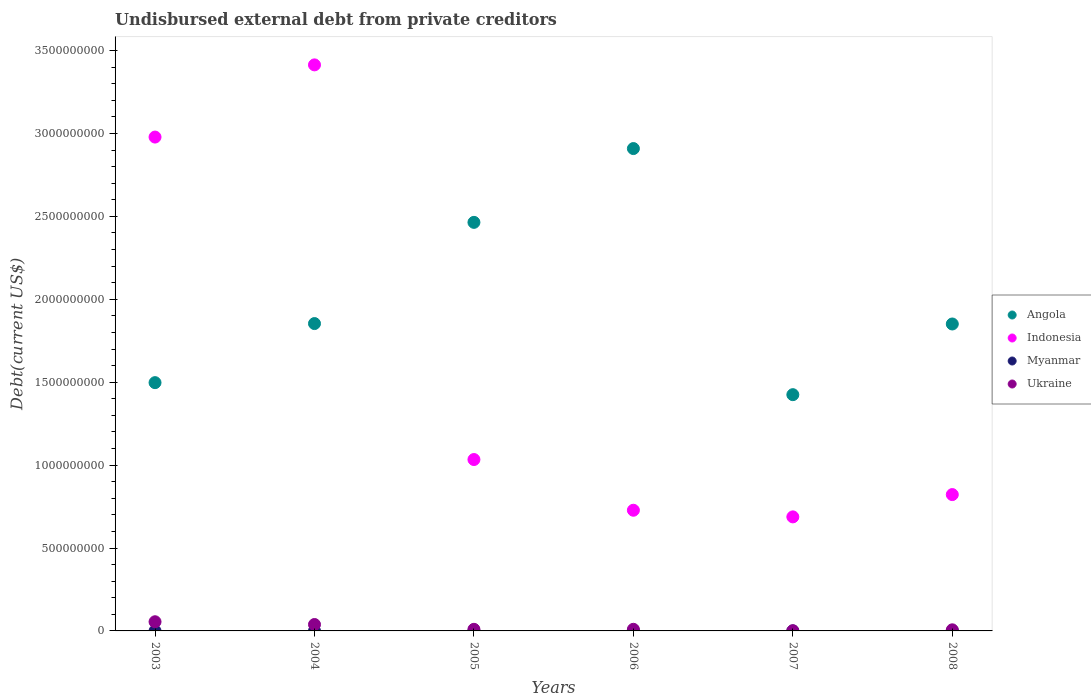Is the number of dotlines equal to the number of legend labels?
Give a very brief answer. Yes. What is the total debt in Ukraine in 2007?
Give a very brief answer. 1.13e+06. Across all years, what is the maximum total debt in Myanmar?
Your answer should be compact. 1.63e+05. Across all years, what is the minimum total debt in Indonesia?
Ensure brevity in your answer.  6.88e+08. In which year was the total debt in Indonesia maximum?
Provide a short and direct response. 2004. What is the total total debt in Angola in the graph?
Provide a succinct answer. 1.20e+1. What is the difference between the total debt in Ukraine in 2006 and that in 2008?
Keep it short and to the point. 3.13e+06. What is the difference between the total debt in Myanmar in 2003 and the total debt in Angola in 2007?
Offer a terse response. -1.42e+09. What is the average total debt in Angola per year?
Offer a very short reply. 2.00e+09. In the year 2008, what is the difference between the total debt in Indonesia and total debt in Myanmar?
Your answer should be very brief. 8.22e+08. Is the total debt in Indonesia in 2004 less than that in 2007?
Offer a very short reply. No. Is the difference between the total debt in Indonesia in 2003 and 2006 greater than the difference between the total debt in Myanmar in 2003 and 2006?
Your answer should be very brief. Yes. What is the difference between the highest and the second highest total debt in Ukraine?
Ensure brevity in your answer.  1.66e+07. What is the difference between the highest and the lowest total debt in Angola?
Make the answer very short. 1.48e+09. Is it the case that in every year, the sum of the total debt in Indonesia and total debt in Myanmar  is greater than the sum of total debt in Ukraine and total debt in Angola?
Offer a very short reply. Yes. Does the total debt in Indonesia monotonically increase over the years?
Make the answer very short. No. Is the total debt in Angola strictly greater than the total debt in Myanmar over the years?
Offer a very short reply. Yes. How many years are there in the graph?
Ensure brevity in your answer.  6. What is the difference between two consecutive major ticks on the Y-axis?
Make the answer very short. 5.00e+08. Where does the legend appear in the graph?
Provide a short and direct response. Center right. How many legend labels are there?
Your answer should be very brief. 4. What is the title of the graph?
Provide a succinct answer. Undisbursed external debt from private creditors. What is the label or title of the X-axis?
Give a very brief answer. Years. What is the label or title of the Y-axis?
Offer a very short reply. Debt(current US$). What is the Debt(current US$) of Angola in 2003?
Give a very brief answer. 1.50e+09. What is the Debt(current US$) in Indonesia in 2003?
Make the answer very short. 2.98e+09. What is the Debt(current US$) in Myanmar in 2003?
Keep it short and to the point. 1.63e+05. What is the Debt(current US$) in Ukraine in 2003?
Provide a short and direct response. 5.53e+07. What is the Debt(current US$) in Angola in 2004?
Keep it short and to the point. 1.85e+09. What is the Debt(current US$) of Indonesia in 2004?
Make the answer very short. 3.41e+09. What is the Debt(current US$) in Myanmar in 2004?
Offer a terse response. 4.70e+04. What is the Debt(current US$) in Ukraine in 2004?
Keep it short and to the point. 3.87e+07. What is the Debt(current US$) of Angola in 2005?
Offer a very short reply. 2.46e+09. What is the Debt(current US$) in Indonesia in 2005?
Your answer should be very brief. 1.03e+09. What is the Debt(current US$) in Myanmar in 2005?
Offer a very short reply. 4.70e+04. What is the Debt(current US$) in Ukraine in 2005?
Your response must be concise. 9.66e+06. What is the Debt(current US$) in Angola in 2006?
Your answer should be compact. 2.91e+09. What is the Debt(current US$) of Indonesia in 2006?
Provide a succinct answer. 7.28e+08. What is the Debt(current US$) in Myanmar in 2006?
Your answer should be very brief. 4.70e+04. What is the Debt(current US$) in Ukraine in 2006?
Give a very brief answer. 9.76e+06. What is the Debt(current US$) of Angola in 2007?
Provide a short and direct response. 1.42e+09. What is the Debt(current US$) of Indonesia in 2007?
Give a very brief answer. 6.88e+08. What is the Debt(current US$) in Myanmar in 2007?
Your response must be concise. 4.70e+04. What is the Debt(current US$) of Ukraine in 2007?
Ensure brevity in your answer.  1.13e+06. What is the Debt(current US$) of Angola in 2008?
Give a very brief answer. 1.85e+09. What is the Debt(current US$) in Indonesia in 2008?
Keep it short and to the point. 8.22e+08. What is the Debt(current US$) in Myanmar in 2008?
Offer a very short reply. 4.70e+04. What is the Debt(current US$) in Ukraine in 2008?
Your response must be concise. 6.63e+06. Across all years, what is the maximum Debt(current US$) of Angola?
Your answer should be compact. 2.91e+09. Across all years, what is the maximum Debt(current US$) of Indonesia?
Keep it short and to the point. 3.41e+09. Across all years, what is the maximum Debt(current US$) of Myanmar?
Offer a very short reply. 1.63e+05. Across all years, what is the maximum Debt(current US$) in Ukraine?
Ensure brevity in your answer.  5.53e+07. Across all years, what is the minimum Debt(current US$) in Angola?
Ensure brevity in your answer.  1.42e+09. Across all years, what is the minimum Debt(current US$) of Indonesia?
Ensure brevity in your answer.  6.88e+08. Across all years, what is the minimum Debt(current US$) in Myanmar?
Provide a short and direct response. 4.70e+04. Across all years, what is the minimum Debt(current US$) in Ukraine?
Your answer should be very brief. 1.13e+06. What is the total Debt(current US$) of Angola in the graph?
Offer a very short reply. 1.20e+1. What is the total Debt(current US$) of Indonesia in the graph?
Your response must be concise. 9.66e+09. What is the total Debt(current US$) of Myanmar in the graph?
Offer a terse response. 3.98e+05. What is the total Debt(current US$) in Ukraine in the graph?
Your answer should be compact. 1.21e+08. What is the difference between the Debt(current US$) in Angola in 2003 and that in 2004?
Provide a succinct answer. -3.56e+08. What is the difference between the Debt(current US$) in Indonesia in 2003 and that in 2004?
Your answer should be compact. -4.35e+08. What is the difference between the Debt(current US$) in Myanmar in 2003 and that in 2004?
Make the answer very short. 1.16e+05. What is the difference between the Debt(current US$) in Ukraine in 2003 and that in 2004?
Offer a terse response. 1.66e+07. What is the difference between the Debt(current US$) of Angola in 2003 and that in 2005?
Your response must be concise. -9.67e+08. What is the difference between the Debt(current US$) in Indonesia in 2003 and that in 2005?
Ensure brevity in your answer.  1.94e+09. What is the difference between the Debt(current US$) of Myanmar in 2003 and that in 2005?
Offer a terse response. 1.16e+05. What is the difference between the Debt(current US$) in Ukraine in 2003 and that in 2005?
Your answer should be compact. 4.56e+07. What is the difference between the Debt(current US$) in Angola in 2003 and that in 2006?
Provide a succinct answer. -1.41e+09. What is the difference between the Debt(current US$) in Indonesia in 2003 and that in 2006?
Ensure brevity in your answer.  2.25e+09. What is the difference between the Debt(current US$) of Myanmar in 2003 and that in 2006?
Provide a short and direct response. 1.16e+05. What is the difference between the Debt(current US$) of Ukraine in 2003 and that in 2006?
Your answer should be very brief. 4.55e+07. What is the difference between the Debt(current US$) in Angola in 2003 and that in 2007?
Ensure brevity in your answer.  7.25e+07. What is the difference between the Debt(current US$) of Indonesia in 2003 and that in 2007?
Provide a short and direct response. 2.29e+09. What is the difference between the Debt(current US$) in Myanmar in 2003 and that in 2007?
Make the answer very short. 1.16e+05. What is the difference between the Debt(current US$) in Ukraine in 2003 and that in 2007?
Provide a succinct answer. 5.42e+07. What is the difference between the Debt(current US$) of Angola in 2003 and that in 2008?
Your answer should be compact. -3.54e+08. What is the difference between the Debt(current US$) in Indonesia in 2003 and that in 2008?
Offer a very short reply. 2.16e+09. What is the difference between the Debt(current US$) in Myanmar in 2003 and that in 2008?
Keep it short and to the point. 1.16e+05. What is the difference between the Debt(current US$) of Ukraine in 2003 and that in 2008?
Your response must be concise. 4.87e+07. What is the difference between the Debt(current US$) in Angola in 2004 and that in 2005?
Provide a succinct answer. -6.10e+08. What is the difference between the Debt(current US$) in Indonesia in 2004 and that in 2005?
Keep it short and to the point. 2.38e+09. What is the difference between the Debt(current US$) of Myanmar in 2004 and that in 2005?
Make the answer very short. 0. What is the difference between the Debt(current US$) in Ukraine in 2004 and that in 2005?
Provide a short and direct response. 2.90e+07. What is the difference between the Debt(current US$) in Angola in 2004 and that in 2006?
Your response must be concise. -1.06e+09. What is the difference between the Debt(current US$) in Indonesia in 2004 and that in 2006?
Keep it short and to the point. 2.69e+09. What is the difference between the Debt(current US$) in Myanmar in 2004 and that in 2006?
Make the answer very short. 0. What is the difference between the Debt(current US$) in Ukraine in 2004 and that in 2006?
Provide a succinct answer. 2.89e+07. What is the difference between the Debt(current US$) of Angola in 2004 and that in 2007?
Your answer should be very brief. 4.29e+08. What is the difference between the Debt(current US$) in Indonesia in 2004 and that in 2007?
Provide a succinct answer. 2.73e+09. What is the difference between the Debt(current US$) in Ukraine in 2004 and that in 2007?
Your answer should be very brief. 3.75e+07. What is the difference between the Debt(current US$) of Angola in 2004 and that in 2008?
Offer a terse response. 2.51e+06. What is the difference between the Debt(current US$) of Indonesia in 2004 and that in 2008?
Give a very brief answer. 2.59e+09. What is the difference between the Debt(current US$) of Ukraine in 2004 and that in 2008?
Keep it short and to the point. 3.20e+07. What is the difference between the Debt(current US$) in Angola in 2005 and that in 2006?
Your answer should be compact. -4.45e+08. What is the difference between the Debt(current US$) of Indonesia in 2005 and that in 2006?
Offer a terse response. 3.06e+08. What is the difference between the Debt(current US$) of Ukraine in 2005 and that in 2006?
Offer a very short reply. -1.05e+05. What is the difference between the Debt(current US$) of Angola in 2005 and that in 2007?
Your response must be concise. 1.04e+09. What is the difference between the Debt(current US$) of Indonesia in 2005 and that in 2007?
Offer a very short reply. 3.46e+08. What is the difference between the Debt(current US$) in Myanmar in 2005 and that in 2007?
Make the answer very short. 0. What is the difference between the Debt(current US$) of Ukraine in 2005 and that in 2007?
Provide a succinct answer. 8.53e+06. What is the difference between the Debt(current US$) of Angola in 2005 and that in 2008?
Ensure brevity in your answer.  6.13e+08. What is the difference between the Debt(current US$) in Indonesia in 2005 and that in 2008?
Give a very brief answer. 2.11e+08. What is the difference between the Debt(current US$) of Ukraine in 2005 and that in 2008?
Offer a terse response. 3.02e+06. What is the difference between the Debt(current US$) of Angola in 2006 and that in 2007?
Provide a short and direct response. 1.48e+09. What is the difference between the Debt(current US$) of Indonesia in 2006 and that in 2007?
Provide a short and direct response. 4.00e+07. What is the difference between the Debt(current US$) of Ukraine in 2006 and that in 2007?
Ensure brevity in your answer.  8.63e+06. What is the difference between the Debt(current US$) of Angola in 2006 and that in 2008?
Offer a terse response. 1.06e+09. What is the difference between the Debt(current US$) in Indonesia in 2006 and that in 2008?
Your answer should be very brief. -9.44e+07. What is the difference between the Debt(current US$) of Myanmar in 2006 and that in 2008?
Provide a short and direct response. 0. What is the difference between the Debt(current US$) in Ukraine in 2006 and that in 2008?
Keep it short and to the point. 3.13e+06. What is the difference between the Debt(current US$) of Angola in 2007 and that in 2008?
Provide a short and direct response. -4.26e+08. What is the difference between the Debt(current US$) of Indonesia in 2007 and that in 2008?
Give a very brief answer. -1.34e+08. What is the difference between the Debt(current US$) of Myanmar in 2007 and that in 2008?
Provide a succinct answer. 0. What is the difference between the Debt(current US$) of Ukraine in 2007 and that in 2008?
Provide a succinct answer. -5.50e+06. What is the difference between the Debt(current US$) of Angola in 2003 and the Debt(current US$) of Indonesia in 2004?
Your answer should be very brief. -1.92e+09. What is the difference between the Debt(current US$) of Angola in 2003 and the Debt(current US$) of Myanmar in 2004?
Keep it short and to the point. 1.50e+09. What is the difference between the Debt(current US$) of Angola in 2003 and the Debt(current US$) of Ukraine in 2004?
Your answer should be very brief. 1.46e+09. What is the difference between the Debt(current US$) of Indonesia in 2003 and the Debt(current US$) of Myanmar in 2004?
Offer a terse response. 2.98e+09. What is the difference between the Debt(current US$) of Indonesia in 2003 and the Debt(current US$) of Ukraine in 2004?
Your answer should be compact. 2.94e+09. What is the difference between the Debt(current US$) in Myanmar in 2003 and the Debt(current US$) in Ukraine in 2004?
Your answer should be compact. -3.85e+07. What is the difference between the Debt(current US$) of Angola in 2003 and the Debt(current US$) of Indonesia in 2005?
Give a very brief answer. 4.64e+08. What is the difference between the Debt(current US$) in Angola in 2003 and the Debt(current US$) in Myanmar in 2005?
Your answer should be very brief. 1.50e+09. What is the difference between the Debt(current US$) of Angola in 2003 and the Debt(current US$) of Ukraine in 2005?
Your response must be concise. 1.49e+09. What is the difference between the Debt(current US$) of Indonesia in 2003 and the Debt(current US$) of Myanmar in 2005?
Keep it short and to the point. 2.98e+09. What is the difference between the Debt(current US$) of Indonesia in 2003 and the Debt(current US$) of Ukraine in 2005?
Offer a terse response. 2.97e+09. What is the difference between the Debt(current US$) in Myanmar in 2003 and the Debt(current US$) in Ukraine in 2005?
Keep it short and to the point. -9.49e+06. What is the difference between the Debt(current US$) of Angola in 2003 and the Debt(current US$) of Indonesia in 2006?
Your answer should be compact. 7.69e+08. What is the difference between the Debt(current US$) in Angola in 2003 and the Debt(current US$) in Myanmar in 2006?
Provide a short and direct response. 1.50e+09. What is the difference between the Debt(current US$) in Angola in 2003 and the Debt(current US$) in Ukraine in 2006?
Ensure brevity in your answer.  1.49e+09. What is the difference between the Debt(current US$) of Indonesia in 2003 and the Debt(current US$) of Myanmar in 2006?
Your answer should be compact. 2.98e+09. What is the difference between the Debt(current US$) of Indonesia in 2003 and the Debt(current US$) of Ukraine in 2006?
Your answer should be very brief. 2.97e+09. What is the difference between the Debt(current US$) in Myanmar in 2003 and the Debt(current US$) in Ukraine in 2006?
Ensure brevity in your answer.  -9.60e+06. What is the difference between the Debt(current US$) of Angola in 2003 and the Debt(current US$) of Indonesia in 2007?
Make the answer very short. 8.10e+08. What is the difference between the Debt(current US$) in Angola in 2003 and the Debt(current US$) in Myanmar in 2007?
Ensure brevity in your answer.  1.50e+09. What is the difference between the Debt(current US$) in Angola in 2003 and the Debt(current US$) in Ukraine in 2007?
Your response must be concise. 1.50e+09. What is the difference between the Debt(current US$) of Indonesia in 2003 and the Debt(current US$) of Myanmar in 2007?
Provide a succinct answer. 2.98e+09. What is the difference between the Debt(current US$) of Indonesia in 2003 and the Debt(current US$) of Ukraine in 2007?
Your response must be concise. 2.98e+09. What is the difference between the Debt(current US$) in Myanmar in 2003 and the Debt(current US$) in Ukraine in 2007?
Your response must be concise. -9.65e+05. What is the difference between the Debt(current US$) in Angola in 2003 and the Debt(current US$) in Indonesia in 2008?
Your answer should be very brief. 6.75e+08. What is the difference between the Debt(current US$) of Angola in 2003 and the Debt(current US$) of Myanmar in 2008?
Ensure brevity in your answer.  1.50e+09. What is the difference between the Debt(current US$) of Angola in 2003 and the Debt(current US$) of Ukraine in 2008?
Your answer should be compact. 1.49e+09. What is the difference between the Debt(current US$) in Indonesia in 2003 and the Debt(current US$) in Myanmar in 2008?
Offer a very short reply. 2.98e+09. What is the difference between the Debt(current US$) in Indonesia in 2003 and the Debt(current US$) in Ukraine in 2008?
Provide a short and direct response. 2.97e+09. What is the difference between the Debt(current US$) of Myanmar in 2003 and the Debt(current US$) of Ukraine in 2008?
Your response must be concise. -6.47e+06. What is the difference between the Debt(current US$) of Angola in 2004 and the Debt(current US$) of Indonesia in 2005?
Offer a very short reply. 8.20e+08. What is the difference between the Debt(current US$) of Angola in 2004 and the Debt(current US$) of Myanmar in 2005?
Provide a short and direct response. 1.85e+09. What is the difference between the Debt(current US$) in Angola in 2004 and the Debt(current US$) in Ukraine in 2005?
Your answer should be compact. 1.84e+09. What is the difference between the Debt(current US$) of Indonesia in 2004 and the Debt(current US$) of Myanmar in 2005?
Make the answer very short. 3.41e+09. What is the difference between the Debt(current US$) of Indonesia in 2004 and the Debt(current US$) of Ukraine in 2005?
Keep it short and to the point. 3.40e+09. What is the difference between the Debt(current US$) in Myanmar in 2004 and the Debt(current US$) in Ukraine in 2005?
Offer a very short reply. -9.61e+06. What is the difference between the Debt(current US$) of Angola in 2004 and the Debt(current US$) of Indonesia in 2006?
Make the answer very short. 1.13e+09. What is the difference between the Debt(current US$) of Angola in 2004 and the Debt(current US$) of Myanmar in 2006?
Give a very brief answer. 1.85e+09. What is the difference between the Debt(current US$) of Angola in 2004 and the Debt(current US$) of Ukraine in 2006?
Make the answer very short. 1.84e+09. What is the difference between the Debt(current US$) of Indonesia in 2004 and the Debt(current US$) of Myanmar in 2006?
Make the answer very short. 3.41e+09. What is the difference between the Debt(current US$) in Indonesia in 2004 and the Debt(current US$) in Ukraine in 2006?
Offer a very short reply. 3.40e+09. What is the difference between the Debt(current US$) in Myanmar in 2004 and the Debt(current US$) in Ukraine in 2006?
Provide a succinct answer. -9.71e+06. What is the difference between the Debt(current US$) in Angola in 2004 and the Debt(current US$) in Indonesia in 2007?
Ensure brevity in your answer.  1.17e+09. What is the difference between the Debt(current US$) of Angola in 2004 and the Debt(current US$) of Myanmar in 2007?
Your answer should be very brief. 1.85e+09. What is the difference between the Debt(current US$) in Angola in 2004 and the Debt(current US$) in Ukraine in 2007?
Keep it short and to the point. 1.85e+09. What is the difference between the Debt(current US$) in Indonesia in 2004 and the Debt(current US$) in Myanmar in 2007?
Make the answer very short. 3.41e+09. What is the difference between the Debt(current US$) of Indonesia in 2004 and the Debt(current US$) of Ukraine in 2007?
Make the answer very short. 3.41e+09. What is the difference between the Debt(current US$) in Myanmar in 2004 and the Debt(current US$) in Ukraine in 2007?
Offer a very short reply. -1.08e+06. What is the difference between the Debt(current US$) of Angola in 2004 and the Debt(current US$) of Indonesia in 2008?
Ensure brevity in your answer.  1.03e+09. What is the difference between the Debt(current US$) of Angola in 2004 and the Debt(current US$) of Myanmar in 2008?
Your answer should be very brief. 1.85e+09. What is the difference between the Debt(current US$) of Angola in 2004 and the Debt(current US$) of Ukraine in 2008?
Provide a short and direct response. 1.85e+09. What is the difference between the Debt(current US$) of Indonesia in 2004 and the Debt(current US$) of Myanmar in 2008?
Provide a succinct answer. 3.41e+09. What is the difference between the Debt(current US$) of Indonesia in 2004 and the Debt(current US$) of Ukraine in 2008?
Offer a terse response. 3.41e+09. What is the difference between the Debt(current US$) in Myanmar in 2004 and the Debt(current US$) in Ukraine in 2008?
Offer a very short reply. -6.59e+06. What is the difference between the Debt(current US$) in Angola in 2005 and the Debt(current US$) in Indonesia in 2006?
Your response must be concise. 1.74e+09. What is the difference between the Debt(current US$) in Angola in 2005 and the Debt(current US$) in Myanmar in 2006?
Your answer should be compact. 2.46e+09. What is the difference between the Debt(current US$) in Angola in 2005 and the Debt(current US$) in Ukraine in 2006?
Provide a succinct answer. 2.45e+09. What is the difference between the Debt(current US$) in Indonesia in 2005 and the Debt(current US$) in Myanmar in 2006?
Offer a very short reply. 1.03e+09. What is the difference between the Debt(current US$) of Indonesia in 2005 and the Debt(current US$) of Ukraine in 2006?
Your answer should be compact. 1.02e+09. What is the difference between the Debt(current US$) in Myanmar in 2005 and the Debt(current US$) in Ukraine in 2006?
Ensure brevity in your answer.  -9.71e+06. What is the difference between the Debt(current US$) of Angola in 2005 and the Debt(current US$) of Indonesia in 2007?
Provide a succinct answer. 1.78e+09. What is the difference between the Debt(current US$) in Angola in 2005 and the Debt(current US$) in Myanmar in 2007?
Your answer should be very brief. 2.46e+09. What is the difference between the Debt(current US$) in Angola in 2005 and the Debt(current US$) in Ukraine in 2007?
Provide a short and direct response. 2.46e+09. What is the difference between the Debt(current US$) of Indonesia in 2005 and the Debt(current US$) of Myanmar in 2007?
Your answer should be very brief. 1.03e+09. What is the difference between the Debt(current US$) in Indonesia in 2005 and the Debt(current US$) in Ukraine in 2007?
Ensure brevity in your answer.  1.03e+09. What is the difference between the Debt(current US$) in Myanmar in 2005 and the Debt(current US$) in Ukraine in 2007?
Offer a terse response. -1.08e+06. What is the difference between the Debt(current US$) of Angola in 2005 and the Debt(current US$) of Indonesia in 2008?
Make the answer very short. 1.64e+09. What is the difference between the Debt(current US$) in Angola in 2005 and the Debt(current US$) in Myanmar in 2008?
Make the answer very short. 2.46e+09. What is the difference between the Debt(current US$) of Angola in 2005 and the Debt(current US$) of Ukraine in 2008?
Make the answer very short. 2.46e+09. What is the difference between the Debt(current US$) in Indonesia in 2005 and the Debt(current US$) in Myanmar in 2008?
Make the answer very short. 1.03e+09. What is the difference between the Debt(current US$) of Indonesia in 2005 and the Debt(current US$) of Ukraine in 2008?
Make the answer very short. 1.03e+09. What is the difference between the Debt(current US$) of Myanmar in 2005 and the Debt(current US$) of Ukraine in 2008?
Offer a terse response. -6.59e+06. What is the difference between the Debt(current US$) of Angola in 2006 and the Debt(current US$) of Indonesia in 2007?
Your response must be concise. 2.22e+09. What is the difference between the Debt(current US$) in Angola in 2006 and the Debt(current US$) in Myanmar in 2007?
Your answer should be very brief. 2.91e+09. What is the difference between the Debt(current US$) of Angola in 2006 and the Debt(current US$) of Ukraine in 2007?
Your response must be concise. 2.91e+09. What is the difference between the Debt(current US$) in Indonesia in 2006 and the Debt(current US$) in Myanmar in 2007?
Provide a succinct answer. 7.28e+08. What is the difference between the Debt(current US$) in Indonesia in 2006 and the Debt(current US$) in Ukraine in 2007?
Your answer should be compact. 7.27e+08. What is the difference between the Debt(current US$) of Myanmar in 2006 and the Debt(current US$) of Ukraine in 2007?
Ensure brevity in your answer.  -1.08e+06. What is the difference between the Debt(current US$) in Angola in 2006 and the Debt(current US$) in Indonesia in 2008?
Your answer should be compact. 2.09e+09. What is the difference between the Debt(current US$) of Angola in 2006 and the Debt(current US$) of Myanmar in 2008?
Provide a short and direct response. 2.91e+09. What is the difference between the Debt(current US$) in Angola in 2006 and the Debt(current US$) in Ukraine in 2008?
Your answer should be very brief. 2.90e+09. What is the difference between the Debt(current US$) of Indonesia in 2006 and the Debt(current US$) of Myanmar in 2008?
Make the answer very short. 7.28e+08. What is the difference between the Debt(current US$) of Indonesia in 2006 and the Debt(current US$) of Ukraine in 2008?
Ensure brevity in your answer.  7.21e+08. What is the difference between the Debt(current US$) of Myanmar in 2006 and the Debt(current US$) of Ukraine in 2008?
Make the answer very short. -6.59e+06. What is the difference between the Debt(current US$) in Angola in 2007 and the Debt(current US$) in Indonesia in 2008?
Offer a terse response. 6.03e+08. What is the difference between the Debt(current US$) of Angola in 2007 and the Debt(current US$) of Myanmar in 2008?
Offer a terse response. 1.42e+09. What is the difference between the Debt(current US$) of Angola in 2007 and the Debt(current US$) of Ukraine in 2008?
Your response must be concise. 1.42e+09. What is the difference between the Debt(current US$) in Indonesia in 2007 and the Debt(current US$) in Myanmar in 2008?
Your answer should be compact. 6.88e+08. What is the difference between the Debt(current US$) of Indonesia in 2007 and the Debt(current US$) of Ukraine in 2008?
Provide a succinct answer. 6.81e+08. What is the difference between the Debt(current US$) of Myanmar in 2007 and the Debt(current US$) of Ukraine in 2008?
Provide a succinct answer. -6.59e+06. What is the average Debt(current US$) of Angola per year?
Offer a very short reply. 2.00e+09. What is the average Debt(current US$) in Indonesia per year?
Provide a short and direct response. 1.61e+09. What is the average Debt(current US$) of Myanmar per year?
Your answer should be compact. 6.63e+04. What is the average Debt(current US$) of Ukraine per year?
Give a very brief answer. 2.02e+07. In the year 2003, what is the difference between the Debt(current US$) of Angola and Debt(current US$) of Indonesia?
Keep it short and to the point. -1.48e+09. In the year 2003, what is the difference between the Debt(current US$) in Angola and Debt(current US$) in Myanmar?
Give a very brief answer. 1.50e+09. In the year 2003, what is the difference between the Debt(current US$) of Angola and Debt(current US$) of Ukraine?
Provide a succinct answer. 1.44e+09. In the year 2003, what is the difference between the Debt(current US$) in Indonesia and Debt(current US$) in Myanmar?
Your answer should be compact. 2.98e+09. In the year 2003, what is the difference between the Debt(current US$) in Indonesia and Debt(current US$) in Ukraine?
Keep it short and to the point. 2.92e+09. In the year 2003, what is the difference between the Debt(current US$) of Myanmar and Debt(current US$) of Ukraine?
Your response must be concise. -5.51e+07. In the year 2004, what is the difference between the Debt(current US$) in Angola and Debt(current US$) in Indonesia?
Ensure brevity in your answer.  -1.56e+09. In the year 2004, what is the difference between the Debt(current US$) of Angola and Debt(current US$) of Myanmar?
Your response must be concise. 1.85e+09. In the year 2004, what is the difference between the Debt(current US$) in Angola and Debt(current US$) in Ukraine?
Provide a succinct answer. 1.81e+09. In the year 2004, what is the difference between the Debt(current US$) of Indonesia and Debt(current US$) of Myanmar?
Keep it short and to the point. 3.41e+09. In the year 2004, what is the difference between the Debt(current US$) of Indonesia and Debt(current US$) of Ukraine?
Provide a succinct answer. 3.37e+09. In the year 2004, what is the difference between the Debt(current US$) in Myanmar and Debt(current US$) in Ukraine?
Your response must be concise. -3.86e+07. In the year 2005, what is the difference between the Debt(current US$) of Angola and Debt(current US$) of Indonesia?
Ensure brevity in your answer.  1.43e+09. In the year 2005, what is the difference between the Debt(current US$) in Angola and Debt(current US$) in Myanmar?
Make the answer very short. 2.46e+09. In the year 2005, what is the difference between the Debt(current US$) of Angola and Debt(current US$) of Ukraine?
Your answer should be very brief. 2.45e+09. In the year 2005, what is the difference between the Debt(current US$) of Indonesia and Debt(current US$) of Myanmar?
Your answer should be very brief. 1.03e+09. In the year 2005, what is the difference between the Debt(current US$) of Indonesia and Debt(current US$) of Ukraine?
Keep it short and to the point. 1.02e+09. In the year 2005, what is the difference between the Debt(current US$) of Myanmar and Debt(current US$) of Ukraine?
Offer a terse response. -9.61e+06. In the year 2006, what is the difference between the Debt(current US$) in Angola and Debt(current US$) in Indonesia?
Make the answer very short. 2.18e+09. In the year 2006, what is the difference between the Debt(current US$) in Angola and Debt(current US$) in Myanmar?
Your answer should be compact. 2.91e+09. In the year 2006, what is the difference between the Debt(current US$) of Angola and Debt(current US$) of Ukraine?
Your answer should be very brief. 2.90e+09. In the year 2006, what is the difference between the Debt(current US$) in Indonesia and Debt(current US$) in Myanmar?
Offer a very short reply. 7.28e+08. In the year 2006, what is the difference between the Debt(current US$) in Indonesia and Debt(current US$) in Ukraine?
Your answer should be very brief. 7.18e+08. In the year 2006, what is the difference between the Debt(current US$) of Myanmar and Debt(current US$) of Ukraine?
Offer a terse response. -9.71e+06. In the year 2007, what is the difference between the Debt(current US$) in Angola and Debt(current US$) in Indonesia?
Give a very brief answer. 7.37e+08. In the year 2007, what is the difference between the Debt(current US$) in Angola and Debt(current US$) in Myanmar?
Provide a short and direct response. 1.42e+09. In the year 2007, what is the difference between the Debt(current US$) in Angola and Debt(current US$) in Ukraine?
Keep it short and to the point. 1.42e+09. In the year 2007, what is the difference between the Debt(current US$) of Indonesia and Debt(current US$) of Myanmar?
Offer a terse response. 6.88e+08. In the year 2007, what is the difference between the Debt(current US$) in Indonesia and Debt(current US$) in Ukraine?
Keep it short and to the point. 6.87e+08. In the year 2007, what is the difference between the Debt(current US$) in Myanmar and Debt(current US$) in Ukraine?
Offer a terse response. -1.08e+06. In the year 2008, what is the difference between the Debt(current US$) of Angola and Debt(current US$) of Indonesia?
Make the answer very short. 1.03e+09. In the year 2008, what is the difference between the Debt(current US$) in Angola and Debt(current US$) in Myanmar?
Your answer should be compact. 1.85e+09. In the year 2008, what is the difference between the Debt(current US$) of Angola and Debt(current US$) of Ukraine?
Provide a short and direct response. 1.84e+09. In the year 2008, what is the difference between the Debt(current US$) in Indonesia and Debt(current US$) in Myanmar?
Provide a short and direct response. 8.22e+08. In the year 2008, what is the difference between the Debt(current US$) in Indonesia and Debt(current US$) in Ukraine?
Provide a succinct answer. 8.16e+08. In the year 2008, what is the difference between the Debt(current US$) of Myanmar and Debt(current US$) of Ukraine?
Keep it short and to the point. -6.59e+06. What is the ratio of the Debt(current US$) of Angola in 2003 to that in 2004?
Your answer should be very brief. 0.81. What is the ratio of the Debt(current US$) of Indonesia in 2003 to that in 2004?
Ensure brevity in your answer.  0.87. What is the ratio of the Debt(current US$) in Myanmar in 2003 to that in 2004?
Keep it short and to the point. 3.47. What is the ratio of the Debt(current US$) of Ukraine in 2003 to that in 2004?
Your answer should be very brief. 1.43. What is the ratio of the Debt(current US$) in Angola in 2003 to that in 2005?
Ensure brevity in your answer.  0.61. What is the ratio of the Debt(current US$) of Indonesia in 2003 to that in 2005?
Your answer should be compact. 2.88. What is the ratio of the Debt(current US$) of Myanmar in 2003 to that in 2005?
Offer a terse response. 3.47. What is the ratio of the Debt(current US$) of Ukraine in 2003 to that in 2005?
Give a very brief answer. 5.73. What is the ratio of the Debt(current US$) in Angola in 2003 to that in 2006?
Offer a terse response. 0.51. What is the ratio of the Debt(current US$) of Indonesia in 2003 to that in 2006?
Offer a very short reply. 4.09. What is the ratio of the Debt(current US$) in Myanmar in 2003 to that in 2006?
Make the answer very short. 3.47. What is the ratio of the Debt(current US$) in Ukraine in 2003 to that in 2006?
Provide a short and direct response. 5.67. What is the ratio of the Debt(current US$) in Angola in 2003 to that in 2007?
Offer a very short reply. 1.05. What is the ratio of the Debt(current US$) of Indonesia in 2003 to that in 2007?
Provide a succinct answer. 4.33. What is the ratio of the Debt(current US$) in Myanmar in 2003 to that in 2007?
Make the answer very short. 3.47. What is the ratio of the Debt(current US$) of Ukraine in 2003 to that in 2007?
Your response must be concise. 49.03. What is the ratio of the Debt(current US$) in Angola in 2003 to that in 2008?
Keep it short and to the point. 0.81. What is the ratio of the Debt(current US$) in Indonesia in 2003 to that in 2008?
Ensure brevity in your answer.  3.62. What is the ratio of the Debt(current US$) of Myanmar in 2003 to that in 2008?
Ensure brevity in your answer.  3.47. What is the ratio of the Debt(current US$) in Ukraine in 2003 to that in 2008?
Ensure brevity in your answer.  8.34. What is the ratio of the Debt(current US$) in Angola in 2004 to that in 2005?
Make the answer very short. 0.75. What is the ratio of the Debt(current US$) in Indonesia in 2004 to that in 2005?
Offer a very short reply. 3.3. What is the ratio of the Debt(current US$) of Ukraine in 2004 to that in 2005?
Provide a succinct answer. 4.01. What is the ratio of the Debt(current US$) of Angola in 2004 to that in 2006?
Make the answer very short. 0.64. What is the ratio of the Debt(current US$) in Indonesia in 2004 to that in 2006?
Your answer should be very brief. 4.69. What is the ratio of the Debt(current US$) of Ukraine in 2004 to that in 2006?
Provide a short and direct response. 3.96. What is the ratio of the Debt(current US$) in Angola in 2004 to that in 2007?
Your answer should be very brief. 1.3. What is the ratio of the Debt(current US$) of Indonesia in 2004 to that in 2007?
Your answer should be compact. 4.96. What is the ratio of the Debt(current US$) in Myanmar in 2004 to that in 2007?
Provide a short and direct response. 1. What is the ratio of the Debt(current US$) of Ukraine in 2004 to that in 2007?
Provide a succinct answer. 34.29. What is the ratio of the Debt(current US$) of Indonesia in 2004 to that in 2008?
Your response must be concise. 4.15. What is the ratio of the Debt(current US$) in Ukraine in 2004 to that in 2008?
Provide a succinct answer. 5.83. What is the ratio of the Debt(current US$) of Angola in 2005 to that in 2006?
Your answer should be compact. 0.85. What is the ratio of the Debt(current US$) in Indonesia in 2005 to that in 2006?
Your answer should be very brief. 1.42. What is the ratio of the Debt(current US$) in Angola in 2005 to that in 2007?
Your answer should be compact. 1.73. What is the ratio of the Debt(current US$) in Indonesia in 2005 to that in 2007?
Your response must be concise. 1.5. What is the ratio of the Debt(current US$) in Ukraine in 2005 to that in 2007?
Keep it short and to the point. 8.56. What is the ratio of the Debt(current US$) of Angola in 2005 to that in 2008?
Offer a very short reply. 1.33. What is the ratio of the Debt(current US$) in Indonesia in 2005 to that in 2008?
Keep it short and to the point. 1.26. What is the ratio of the Debt(current US$) of Myanmar in 2005 to that in 2008?
Give a very brief answer. 1. What is the ratio of the Debt(current US$) of Ukraine in 2005 to that in 2008?
Your response must be concise. 1.46. What is the ratio of the Debt(current US$) in Angola in 2006 to that in 2007?
Offer a very short reply. 2.04. What is the ratio of the Debt(current US$) of Indonesia in 2006 to that in 2007?
Provide a short and direct response. 1.06. What is the ratio of the Debt(current US$) of Myanmar in 2006 to that in 2007?
Ensure brevity in your answer.  1. What is the ratio of the Debt(current US$) of Ukraine in 2006 to that in 2007?
Your answer should be very brief. 8.65. What is the ratio of the Debt(current US$) of Angola in 2006 to that in 2008?
Offer a terse response. 1.57. What is the ratio of the Debt(current US$) in Indonesia in 2006 to that in 2008?
Ensure brevity in your answer.  0.89. What is the ratio of the Debt(current US$) of Ukraine in 2006 to that in 2008?
Your answer should be very brief. 1.47. What is the ratio of the Debt(current US$) in Angola in 2007 to that in 2008?
Keep it short and to the point. 0.77. What is the ratio of the Debt(current US$) in Indonesia in 2007 to that in 2008?
Keep it short and to the point. 0.84. What is the ratio of the Debt(current US$) in Myanmar in 2007 to that in 2008?
Make the answer very short. 1. What is the ratio of the Debt(current US$) of Ukraine in 2007 to that in 2008?
Your answer should be compact. 0.17. What is the difference between the highest and the second highest Debt(current US$) in Angola?
Offer a terse response. 4.45e+08. What is the difference between the highest and the second highest Debt(current US$) in Indonesia?
Your answer should be very brief. 4.35e+08. What is the difference between the highest and the second highest Debt(current US$) in Myanmar?
Your answer should be very brief. 1.16e+05. What is the difference between the highest and the second highest Debt(current US$) of Ukraine?
Your answer should be compact. 1.66e+07. What is the difference between the highest and the lowest Debt(current US$) in Angola?
Your answer should be very brief. 1.48e+09. What is the difference between the highest and the lowest Debt(current US$) of Indonesia?
Give a very brief answer. 2.73e+09. What is the difference between the highest and the lowest Debt(current US$) of Myanmar?
Your answer should be very brief. 1.16e+05. What is the difference between the highest and the lowest Debt(current US$) in Ukraine?
Offer a terse response. 5.42e+07. 